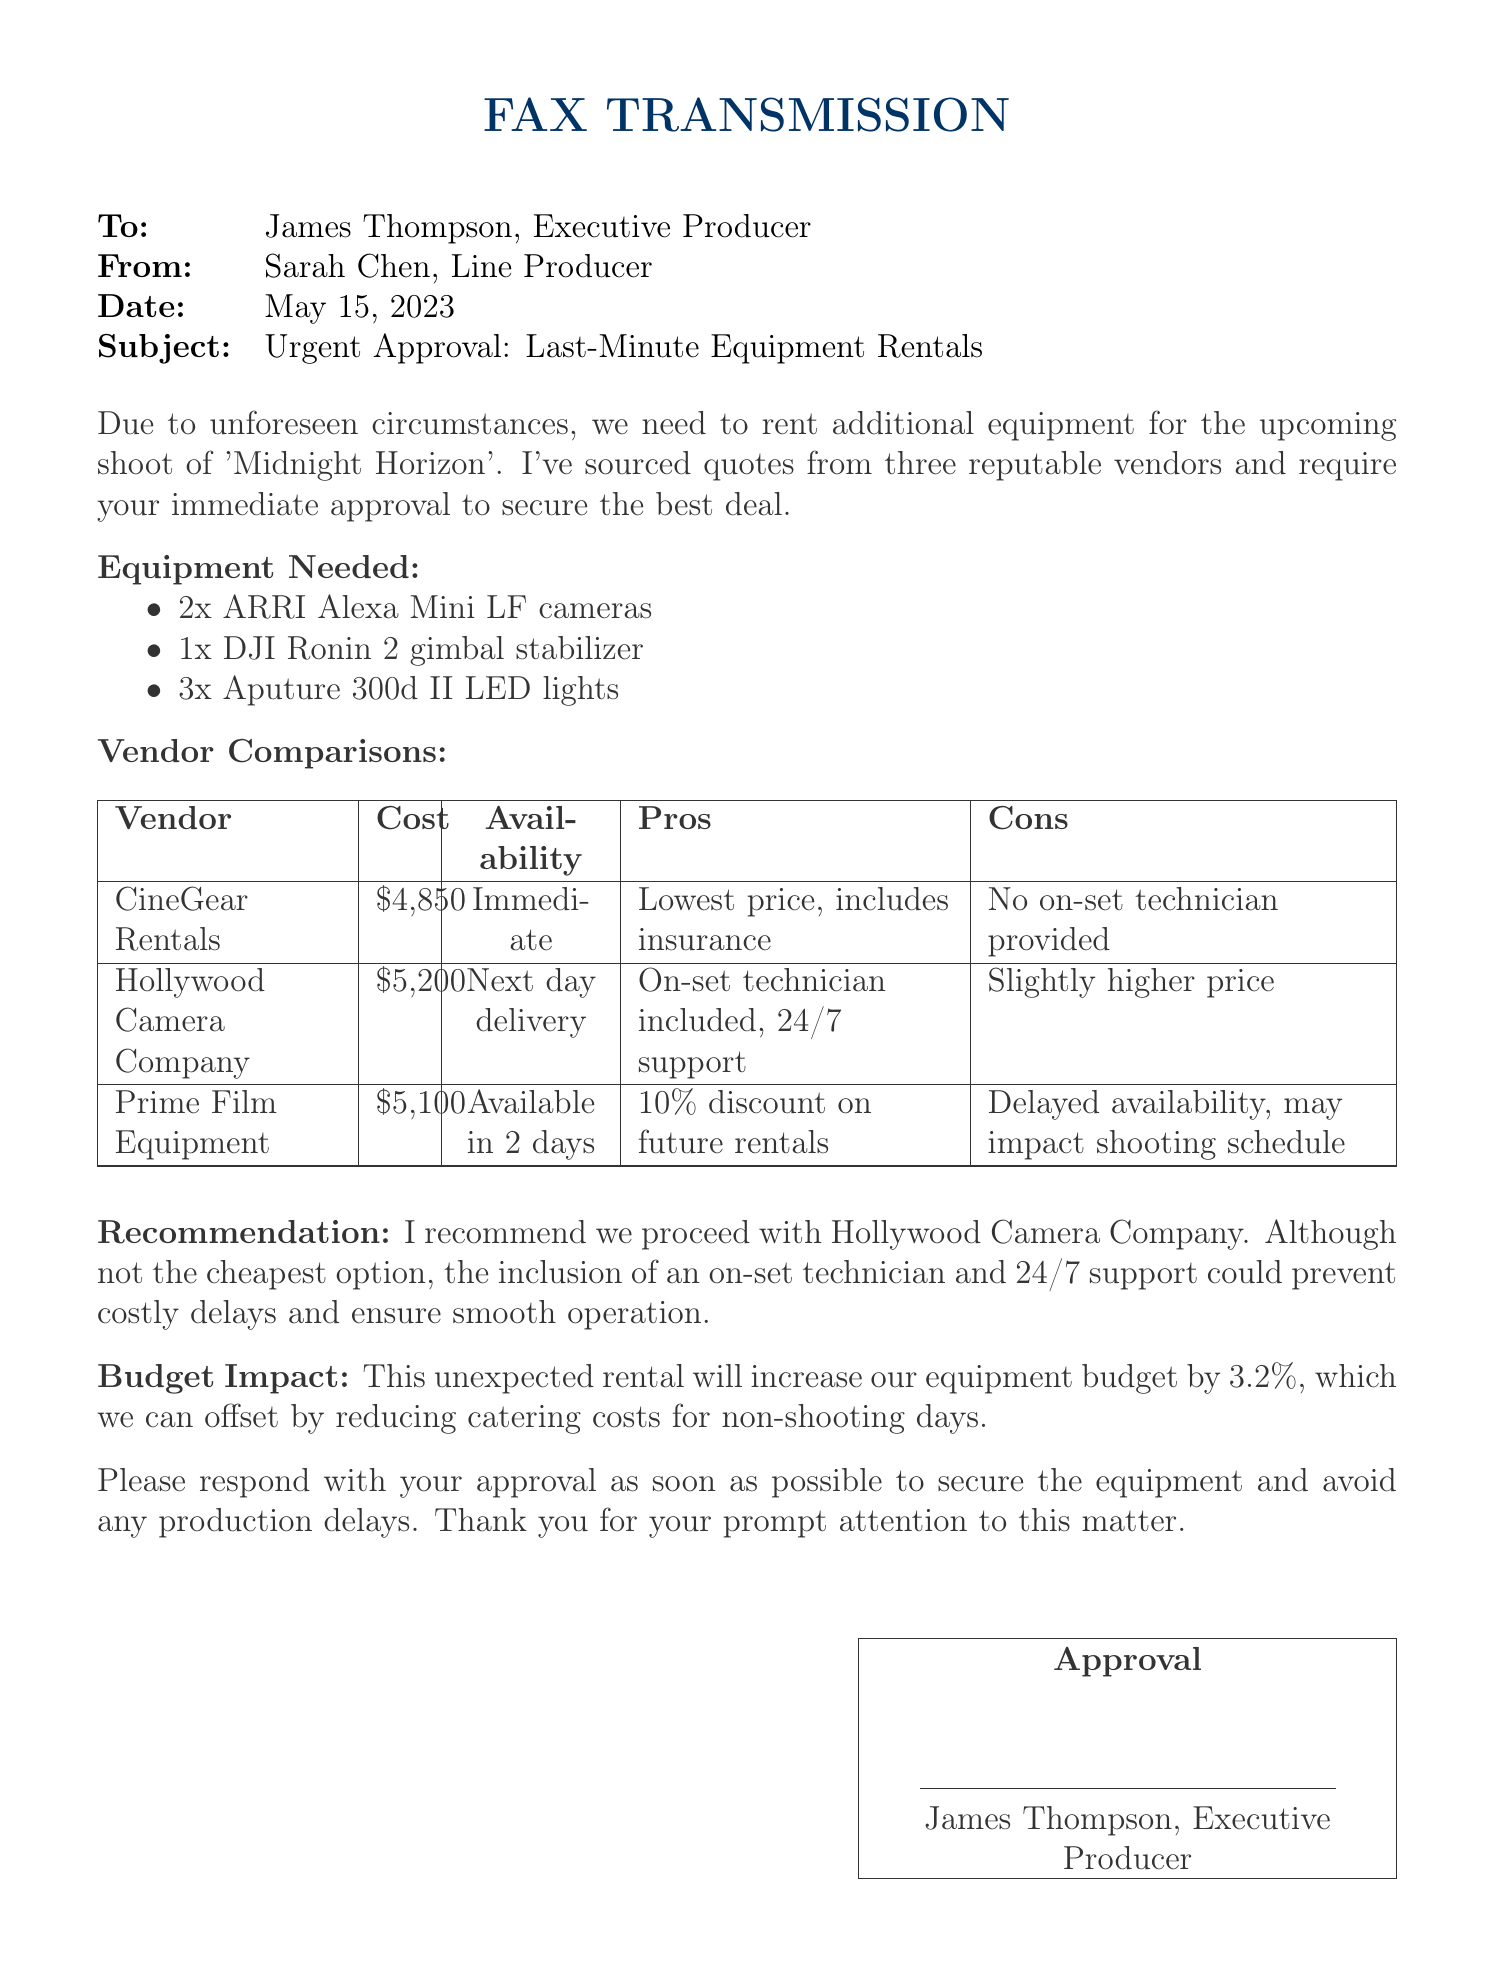what is the subject of the fax? The subject line indicates the main topic discussed in the document.
Answer: Urgent Approval: Last-Minute Equipment Rentals who is the sender of the fax? The sender's information is presented at the top of the fax.
Answer: Sarah Chen what item is recommended for the production? The recommendation section highlights the suggested vendor for rentals.
Answer: Hollywood Camera Company what is the total cost of CineGear Rentals? The cost column lists the amount for each vendor.
Answer: $4,850 how much will the equipment rental increase the budget by? The budget impact section specifies the percentage increase.
Answer: 3.2% what is a disadvantage of using Prime Film Equipment? The cons listed for each vendor provide their respective disadvantages.
Answer: Delayed availability, may impact shooting schedule what equipment type is needed in two units? The equipment list specifies different quantities for each type needed.
Answer: ARRI Alexa Mini LF cameras when is the availability of Hollywood Camera Company? The availability indicates when the equipment can be delivered.
Answer: Next day delivery who must approve the equipment rental? The approval section indicates who is responsible for the final approval.
Answer: James Thompson, Executive Producer 